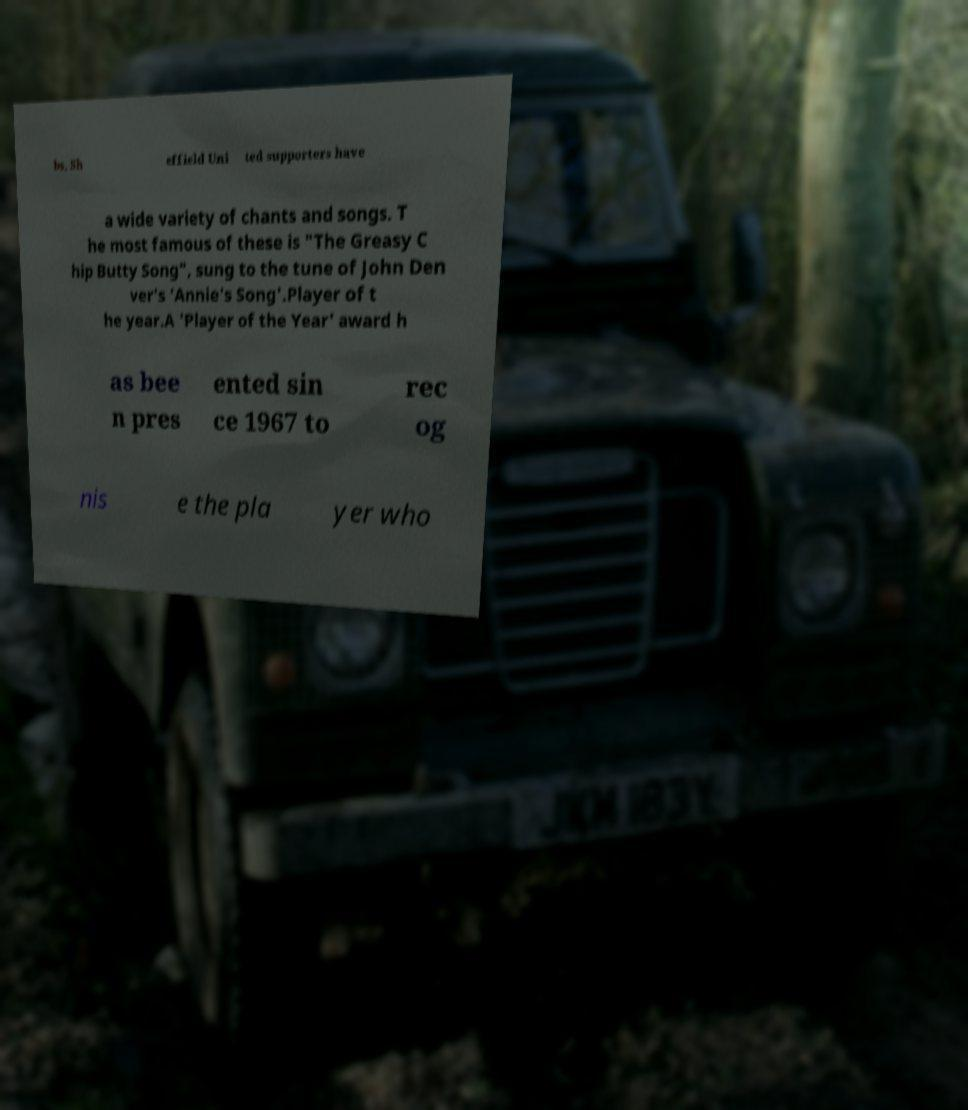Can you accurately transcribe the text from the provided image for me? bs, Sh effield Uni ted supporters have a wide variety of chants and songs. T he most famous of these is "The Greasy C hip Butty Song", sung to the tune of John Den ver's 'Annie's Song'.Player of t he year.A 'Player of the Year' award h as bee n pres ented sin ce 1967 to rec og nis e the pla yer who 